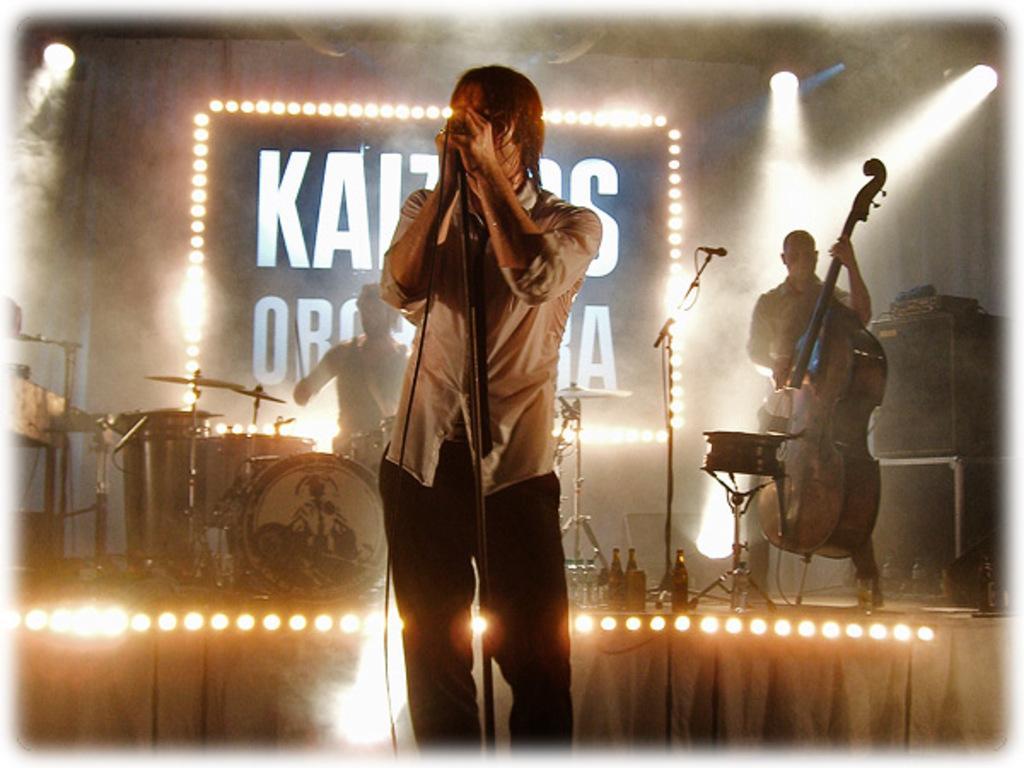In one or two sentences, can you explain what this image depicts? It is a music concert there is a person standing in the front and singing a song,behind this man there are two other people on the stage playing drums and other musical instruments and in the background there is a name of the orchestra and lights around that. 